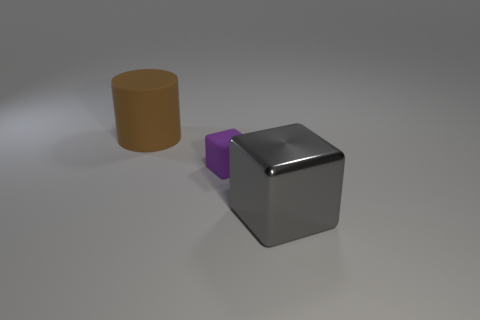Is there anything else that is the same size as the matte cube?
Ensure brevity in your answer.  No. Is there any other thing that is made of the same material as the large block?
Provide a short and direct response. No. How many things are to the left of the rubber cube and in front of the small purple thing?
Your answer should be very brief. 0. What number of rubber objects are either small cubes or cylinders?
Your answer should be very brief. 2. How big is the matte object that is left of the rubber object in front of the brown rubber thing?
Your answer should be very brief. Large. Are there any matte cylinders on the right side of the rubber thing right of the matte object behind the rubber block?
Provide a succinct answer. No. Does the large thing in front of the brown rubber object have the same material as the object left of the tiny cube?
Your response must be concise. No. How many objects are either large cyan metal cylinders or large things left of the tiny purple rubber object?
Your answer should be compact. 1. How many green things are the same shape as the big gray object?
Provide a succinct answer. 0. What material is the other brown object that is the same size as the metal thing?
Ensure brevity in your answer.  Rubber. 